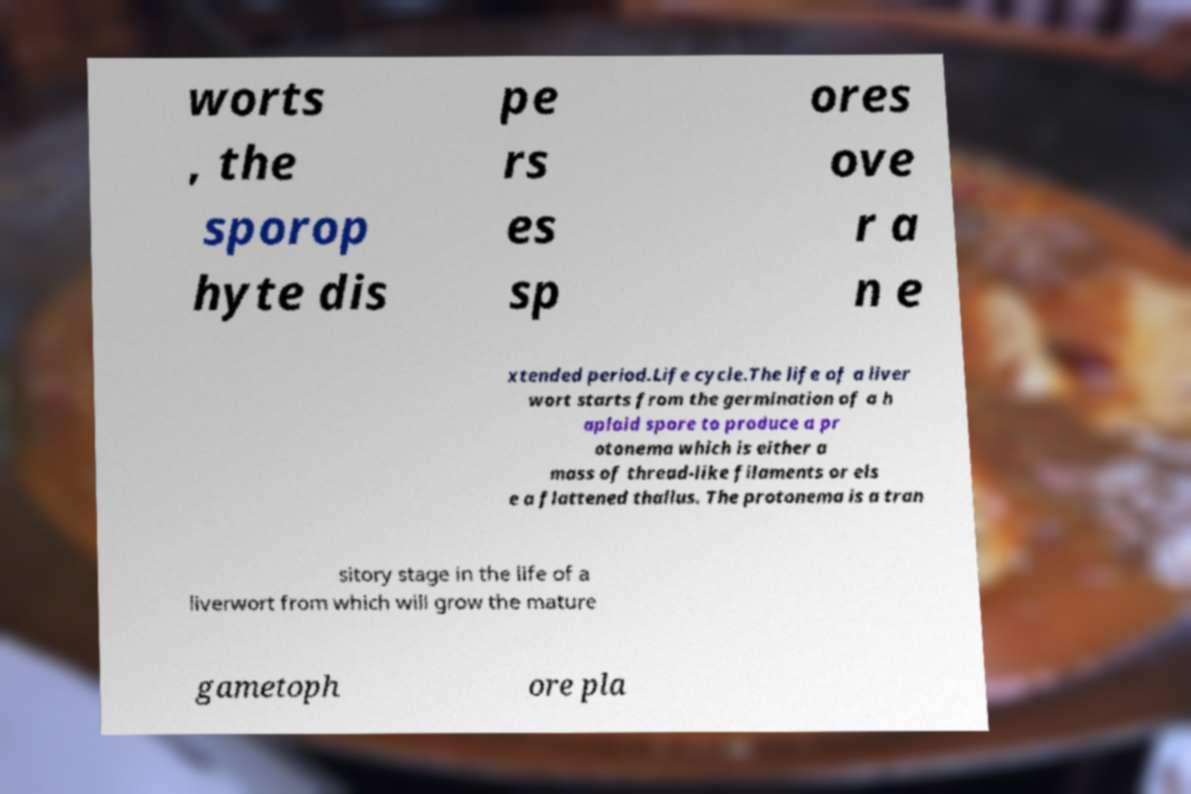For documentation purposes, I need the text within this image transcribed. Could you provide that? worts , the sporop hyte dis pe rs es sp ores ove r a n e xtended period.Life cycle.The life of a liver wort starts from the germination of a h aploid spore to produce a pr otonema which is either a mass of thread-like filaments or els e a flattened thallus. The protonema is a tran sitory stage in the life of a liverwort from which will grow the mature gametoph ore pla 